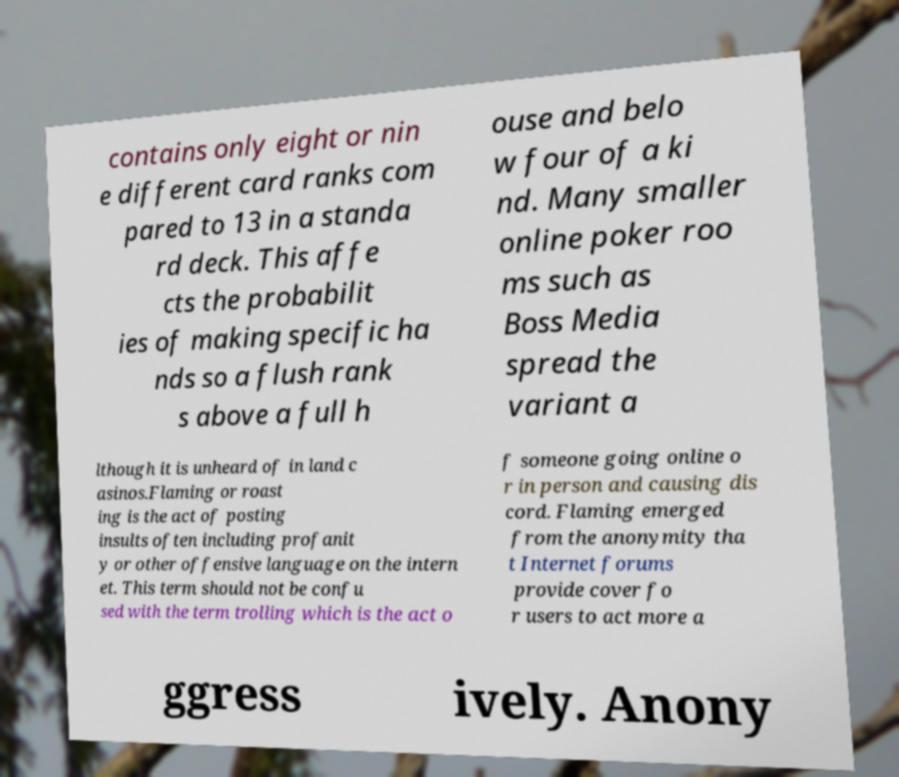Can you accurately transcribe the text from the provided image for me? contains only eight or nin e different card ranks com pared to 13 in a standa rd deck. This affe cts the probabilit ies of making specific ha nds so a flush rank s above a full h ouse and belo w four of a ki nd. Many smaller online poker roo ms such as Boss Media spread the variant a lthough it is unheard of in land c asinos.Flaming or roast ing is the act of posting insults often including profanit y or other offensive language on the intern et. This term should not be confu sed with the term trolling which is the act o f someone going online o r in person and causing dis cord. Flaming emerged from the anonymity tha t Internet forums provide cover fo r users to act more a ggress ively. Anony 